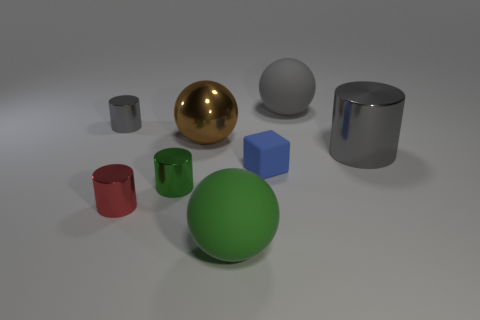Does the big cylinder have the same color as the big sphere behind the tiny gray object?
Keep it short and to the point. Yes. There is a green shiny cylinder in front of the gray matte ball; is its size the same as the gray object that is to the left of the large brown ball?
Your answer should be very brief. Yes. Does the small red metallic object have the same shape as the gray matte object?
Ensure brevity in your answer.  No. How many objects are either balls that are to the right of the brown metallic sphere or small gray balls?
Provide a short and direct response. 2. Are there any green shiny things that have the same shape as the red shiny object?
Ensure brevity in your answer.  Yes. Is the number of things on the right side of the big cylinder the same as the number of big gray matte blocks?
Ensure brevity in your answer.  Yes. What shape is the large rubber object that is the same color as the large cylinder?
Provide a succinct answer. Sphere. How many gray blocks are the same size as the blue matte block?
Give a very brief answer. 0. How many brown metallic objects are left of the green cylinder?
Provide a short and direct response. 0. What material is the large ball that is on the right side of the big ball in front of the small green thing?
Give a very brief answer. Rubber. 